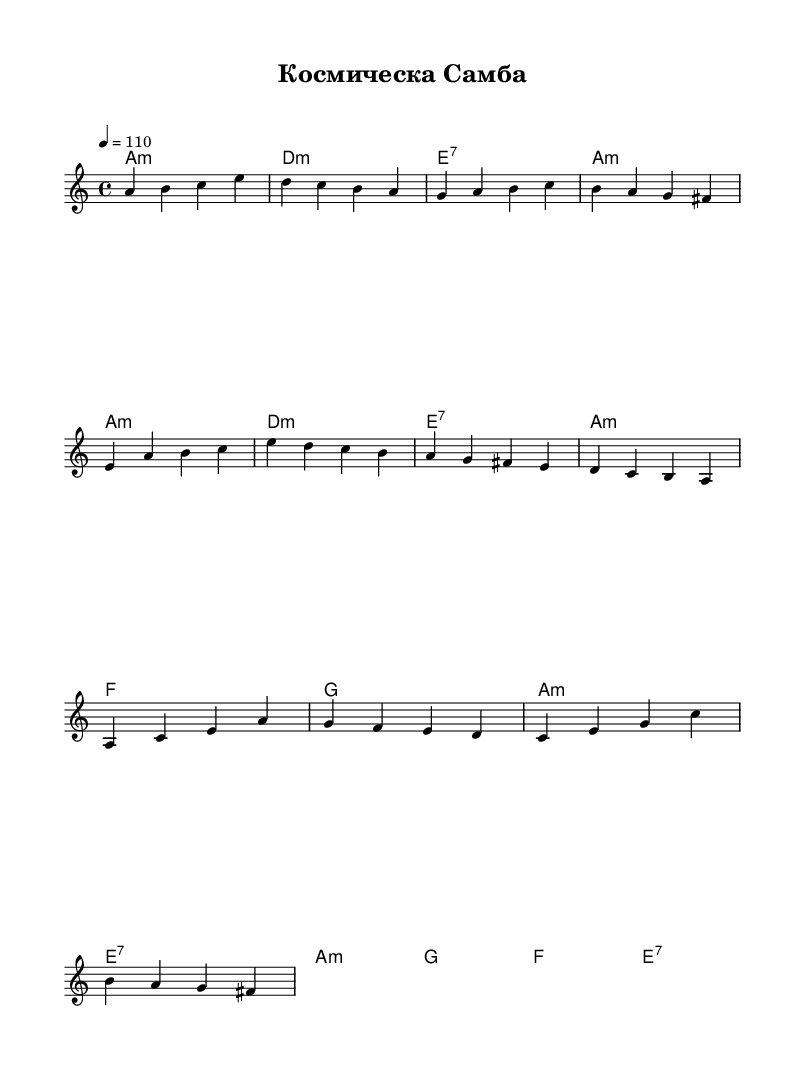What is the key signature of this music? The key signature is A minor, identified by the presence of G sharp (which is not indicated as a sharp in this case). Since there's no key signature indicated in the sheet music, it defaults to A minor.
Answer: A minor What is the time signature of the piece? The time signature is 4/4, as indicated at the beginning of the score. This means there are four beats in each measure, and the quarter note gets one beat.
Answer: 4/4 What is the tempo marking of the piece? The tempo marking is "4 = 110," meaning that the quarter note is set to a speed of 110 beats per minute, guiding the performance speed.
Answer: 110 How many measures are in the verse section? The verse section consists of 4 measures, counting the specific bars in the melody labeled as the verse in the notation.
Answer: 4 What type of chords are predominantly used in the chorus? The chorus uses minor and dominant seventh chords, specifically A minor, G major, F major, and E seventh, indicating the harmonic structure typical for Latin music.
Answer: Minor and dominant seventh What is the primary theme represented in this music? The primary theme involves cosmic or space elements, as suggested by the title "Космическа Самба," which translates to "Cosmic Samba," merging cultural and scientific references in the context.
Answer: Cosmic What rhythmic style does this piece represent? The rhythmic style represents a samba, characterized by syncopated rhythms and lively pacing typical of Latin genres.
Answer: Samba 